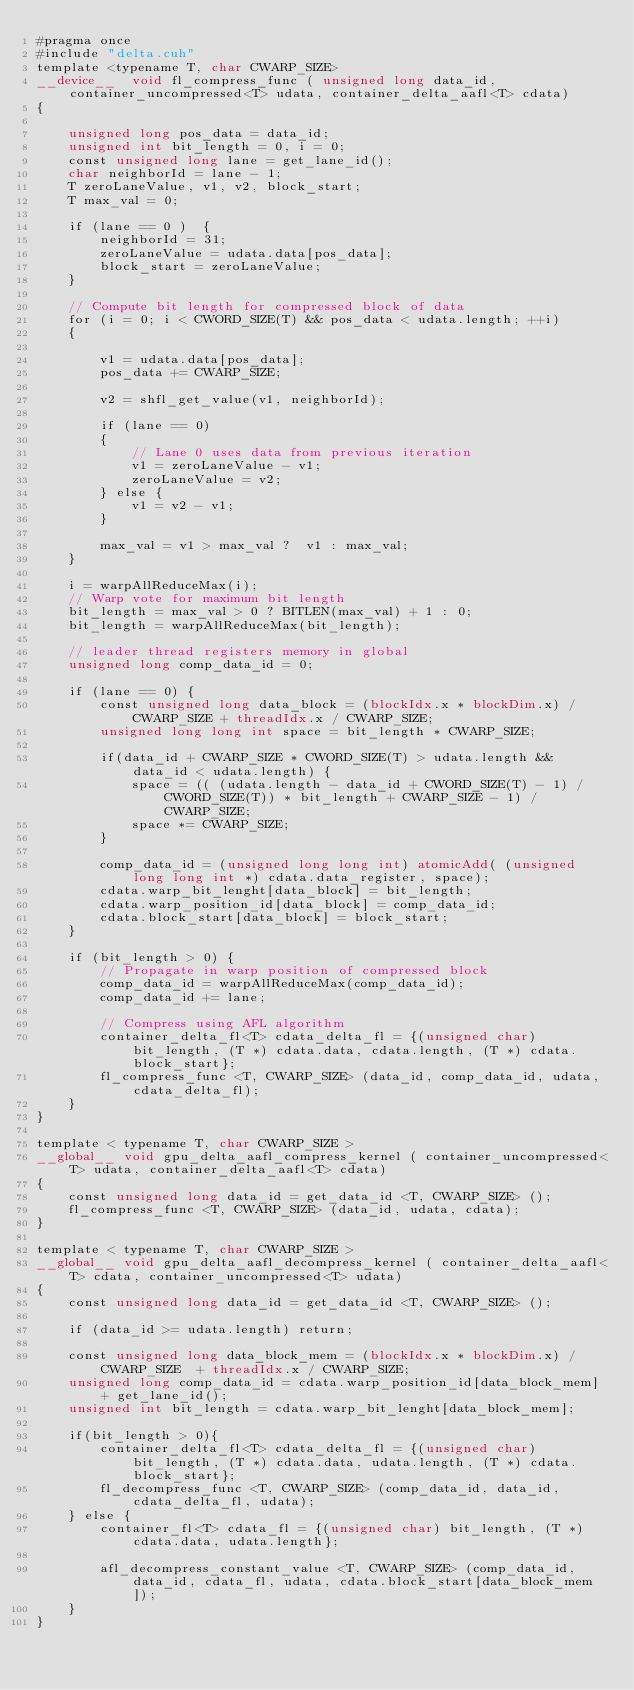Convert code to text. <code><loc_0><loc_0><loc_500><loc_500><_Cuda_>#pragma once
#include "delta.cuh"
template <typename T, char CWARP_SIZE>
__device__  void fl_compress_func ( unsigned long data_id, container_uncompressed<T> udata, container_delta_aafl<T> cdata)
{

    unsigned long pos_data = data_id;
    unsigned int bit_length = 0, i = 0;
    const unsigned long lane = get_lane_id();
    char neighborId = lane - 1;
    T zeroLaneValue, v1, v2, block_start;
    T max_val = 0;

    if (lane == 0 )  {
        neighborId = 31;
        zeroLaneValue = udata.data[pos_data];
        block_start = zeroLaneValue;
    }

    // Compute bit length for compressed block of data
    for (i = 0; i < CWORD_SIZE(T) && pos_data < udata.length; ++i)
    {

        v1 = udata.data[pos_data];
        pos_data += CWARP_SIZE;

        v2 = shfl_get_value(v1, neighborId);

        if (lane == 0)
        {
            // Lane 0 uses data from previous iteration
            v1 = zeroLaneValue - v1;
            zeroLaneValue = v2;
        } else {
            v1 = v2 - v1;
        }

        max_val = v1 > max_val ?  v1 : max_val;
    }

    i = warpAllReduceMax(i);
    // Warp vote for maximum bit length
    bit_length = max_val > 0 ? BITLEN(max_val) + 1 : 0;
    bit_length = warpAllReduceMax(bit_length);

    // leader thread registers memory in global
    unsigned long comp_data_id = 0;

    if (lane == 0) {
        const unsigned long data_block = (blockIdx.x * blockDim.x) / CWARP_SIZE + threadIdx.x / CWARP_SIZE;
        unsigned long long int space = bit_length * CWARP_SIZE;

        if(data_id + CWARP_SIZE * CWORD_SIZE(T) > udata.length && data_id < udata.length) {
            space = (( (udata.length - data_id + CWORD_SIZE(T) - 1) / CWORD_SIZE(T)) * bit_length + CWARP_SIZE - 1) / CWARP_SIZE;
            space *= CWARP_SIZE;
        }

        comp_data_id = (unsigned long long int) atomicAdd( (unsigned long long int *) cdata.data_register, space);
        cdata.warp_bit_lenght[data_block] = bit_length;
        cdata.warp_position_id[data_block] = comp_data_id;
        cdata.block_start[data_block] = block_start;
    }

    if (bit_length > 0) {
        // Propagate in warp position of compressed block
        comp_data_id = warpAllReduceMax(comp_data_id);
        comp_data_id += lane;

        // Compress using AFL algorithm
        container_delta_fl<T> cdata_delta_fl = {(unsigned char) bit_length, (T *) cdata.data, cdata.length, (T *) cdata.block_start};
        fl_compress_func <T, CWARP_SIZE> (data_id, comp_data_id, udata, cdata_delta_fl);
    }
}

template < typename T, char CWARP_SIZE >
__global__ void gpu_delta_aafl_compress_kernel ( container_uncompressed<T> udata, container_delta_aafl<T> cdata)
{
    const unsigned long data_id = get_data_id <T, CWARP_SIZE> ();
    fl_compress_func <T, CWARP_SIZE> (data_id, udata, cdata);
}

template < typename T, char CWARP_SIZE >
__global__ void gpu_delta_aafl_decompress_kernel ( container_delta_aafl<T> cdata, container_uncompressed<T> udata)
{
    const unsigned long data_id = get_data_id <T, CWARP_SIZE> ();

    if (data_id >= udata.length) return;

    const unsigned long data_block_mem = (blockIdx.x * blockDim.x) / CWARP_SIZE  + threadIdx.x / CWARP_SIZE;
    unsigned long comp_data_id = cdata.warp_position_id[data_block_mem] + get_lane_id();
    unsigned int bit_length = cdata.warp_bit_lenght[data_block_mem];

    if(bit_length > 0){
        container_delta_fl<T> cdata_delta_fl = {(unsigned char) bit_length, (T *) cdata.data, udata.length, (T *) cdata.block_start};
        fl_decompress_func <T, CWARP_SIZE> (comp_data_id, data_id, cdata_delta_fl, udata);
    } else {
        container_fl<T> cdata_fl = {(unsigned char) bit_length, (T *) cdata.data, udata.length};

        afl_decompress_constant_value <T, CWARP_SIZE> (comp_data_id, data_id, cdata_fl, udata, cdata.block_start[data_block_mem]);
    }
}

</code> 